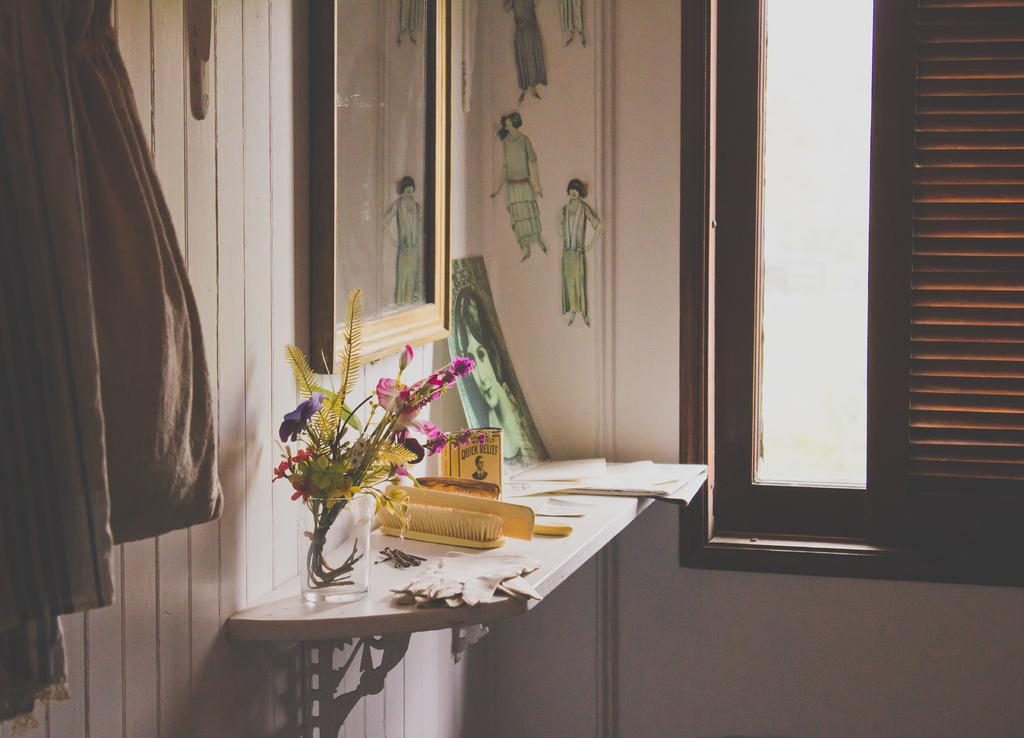What can be seen in the room that provides a view of the outside? There is a window in the room. What can be used for personal grooming in the room? There is a comb and a brush in the room. What is hanging on the wall in the room? There are dresses hanging on the wall. What can be used for displaying items in the room? There is a table stand in the room. What can be used for holding flowers in the room? There is a flower vase in the room. How many pets are visible in the room? There are no pets visible in the room; the provided facts do not mention any pets. What type of mist can be seen in the room? There is no mention of mist in the room; the provided facts do not mention any mist. 